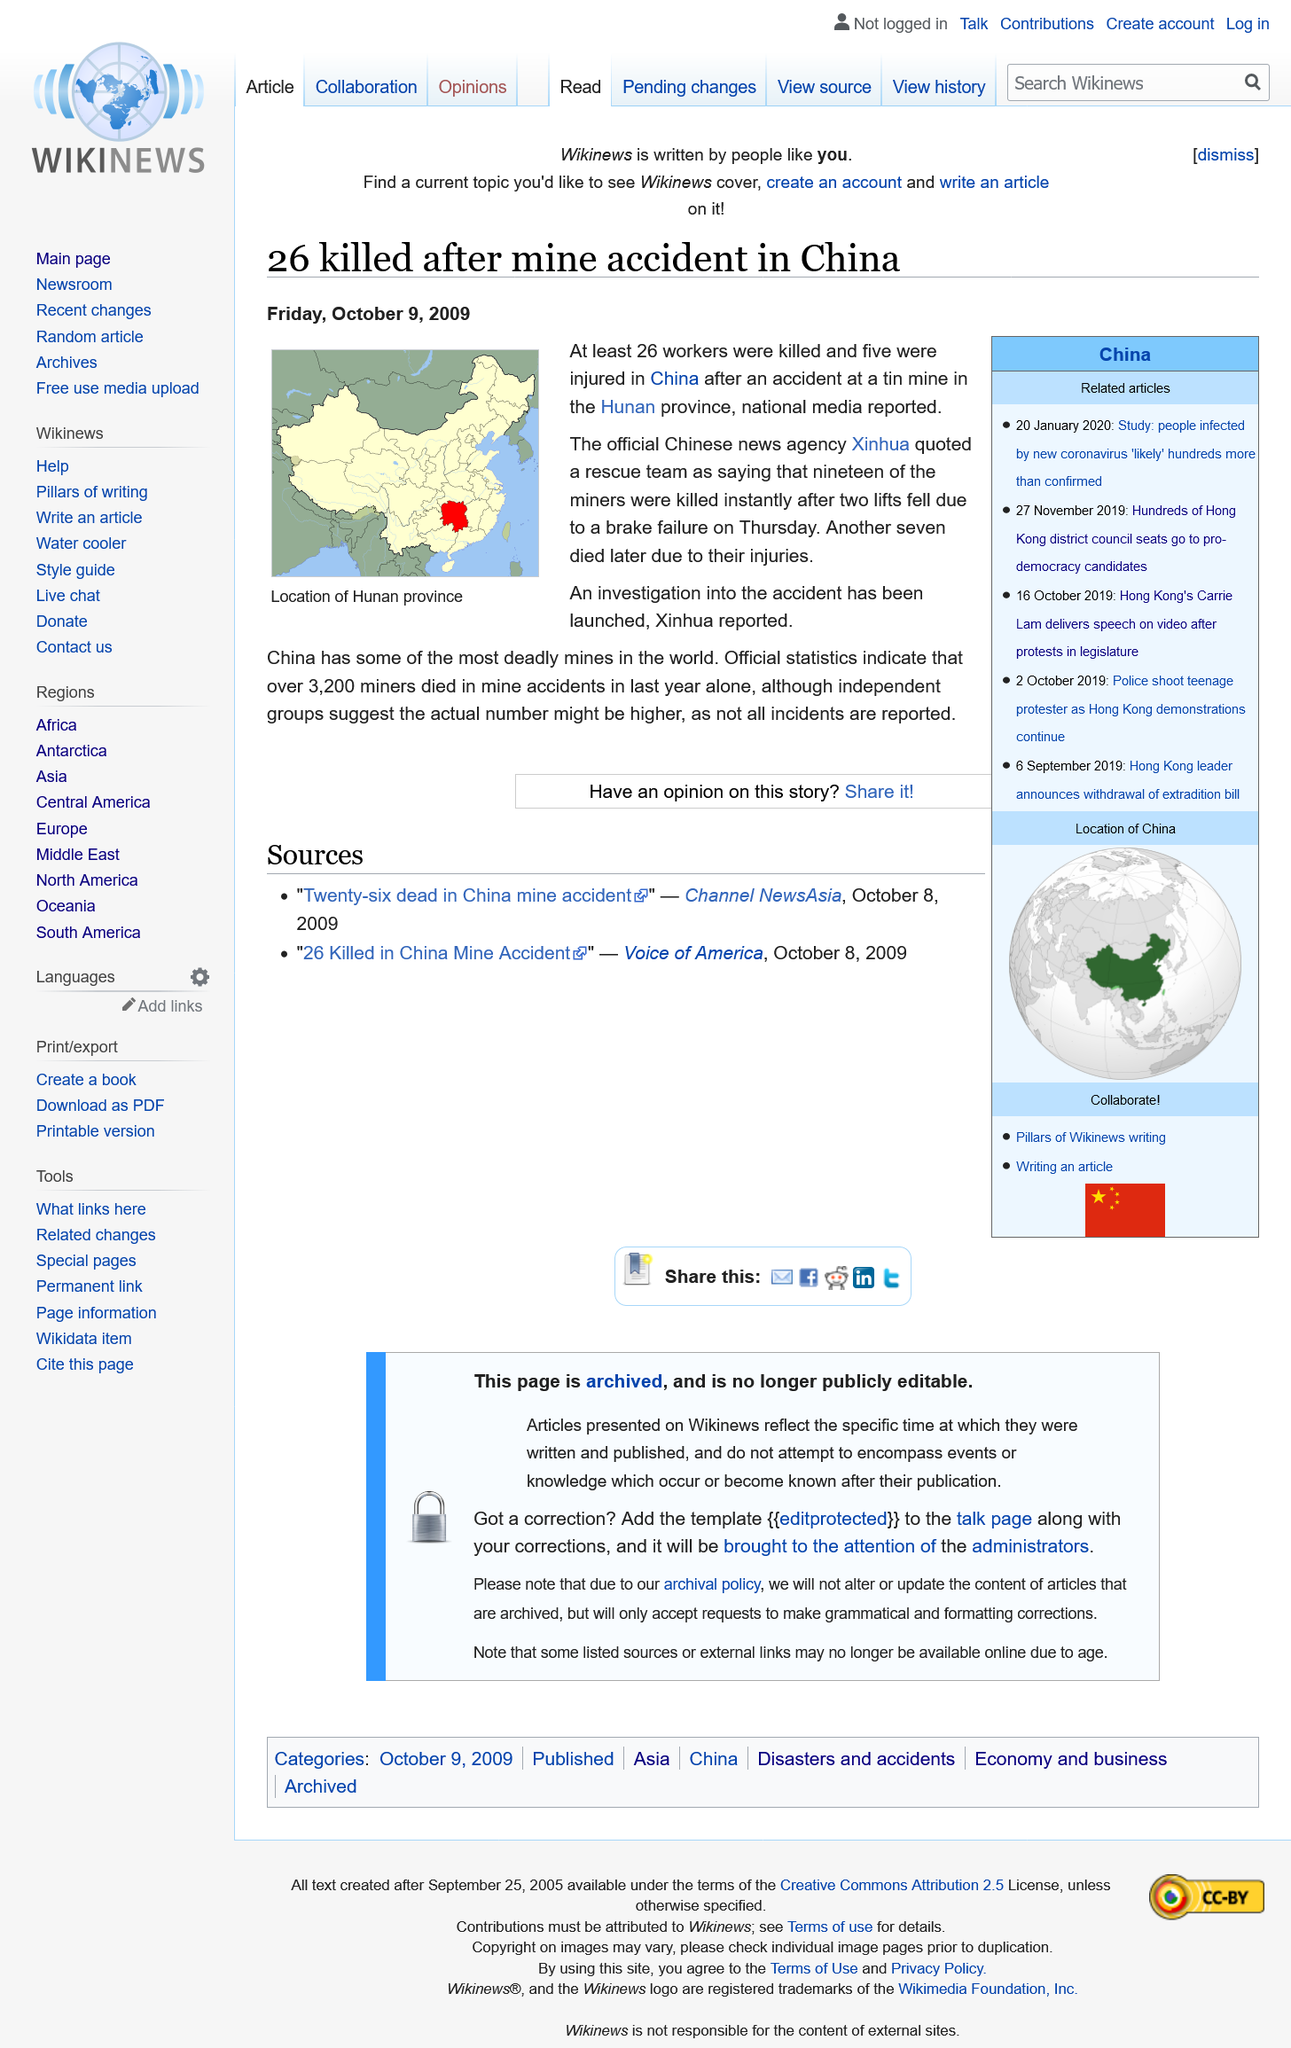List a handful of essential elements in this visual. The accident that occurred was caused by a brake failure in the two lifts, resulting in the deaths of the miners. In the Hunan province of China, a tin mine accident occurred, resulting in the death of the miners. In the past year, a staggering 3,200 miners lost their lives in China due to unsafe working conditions. 